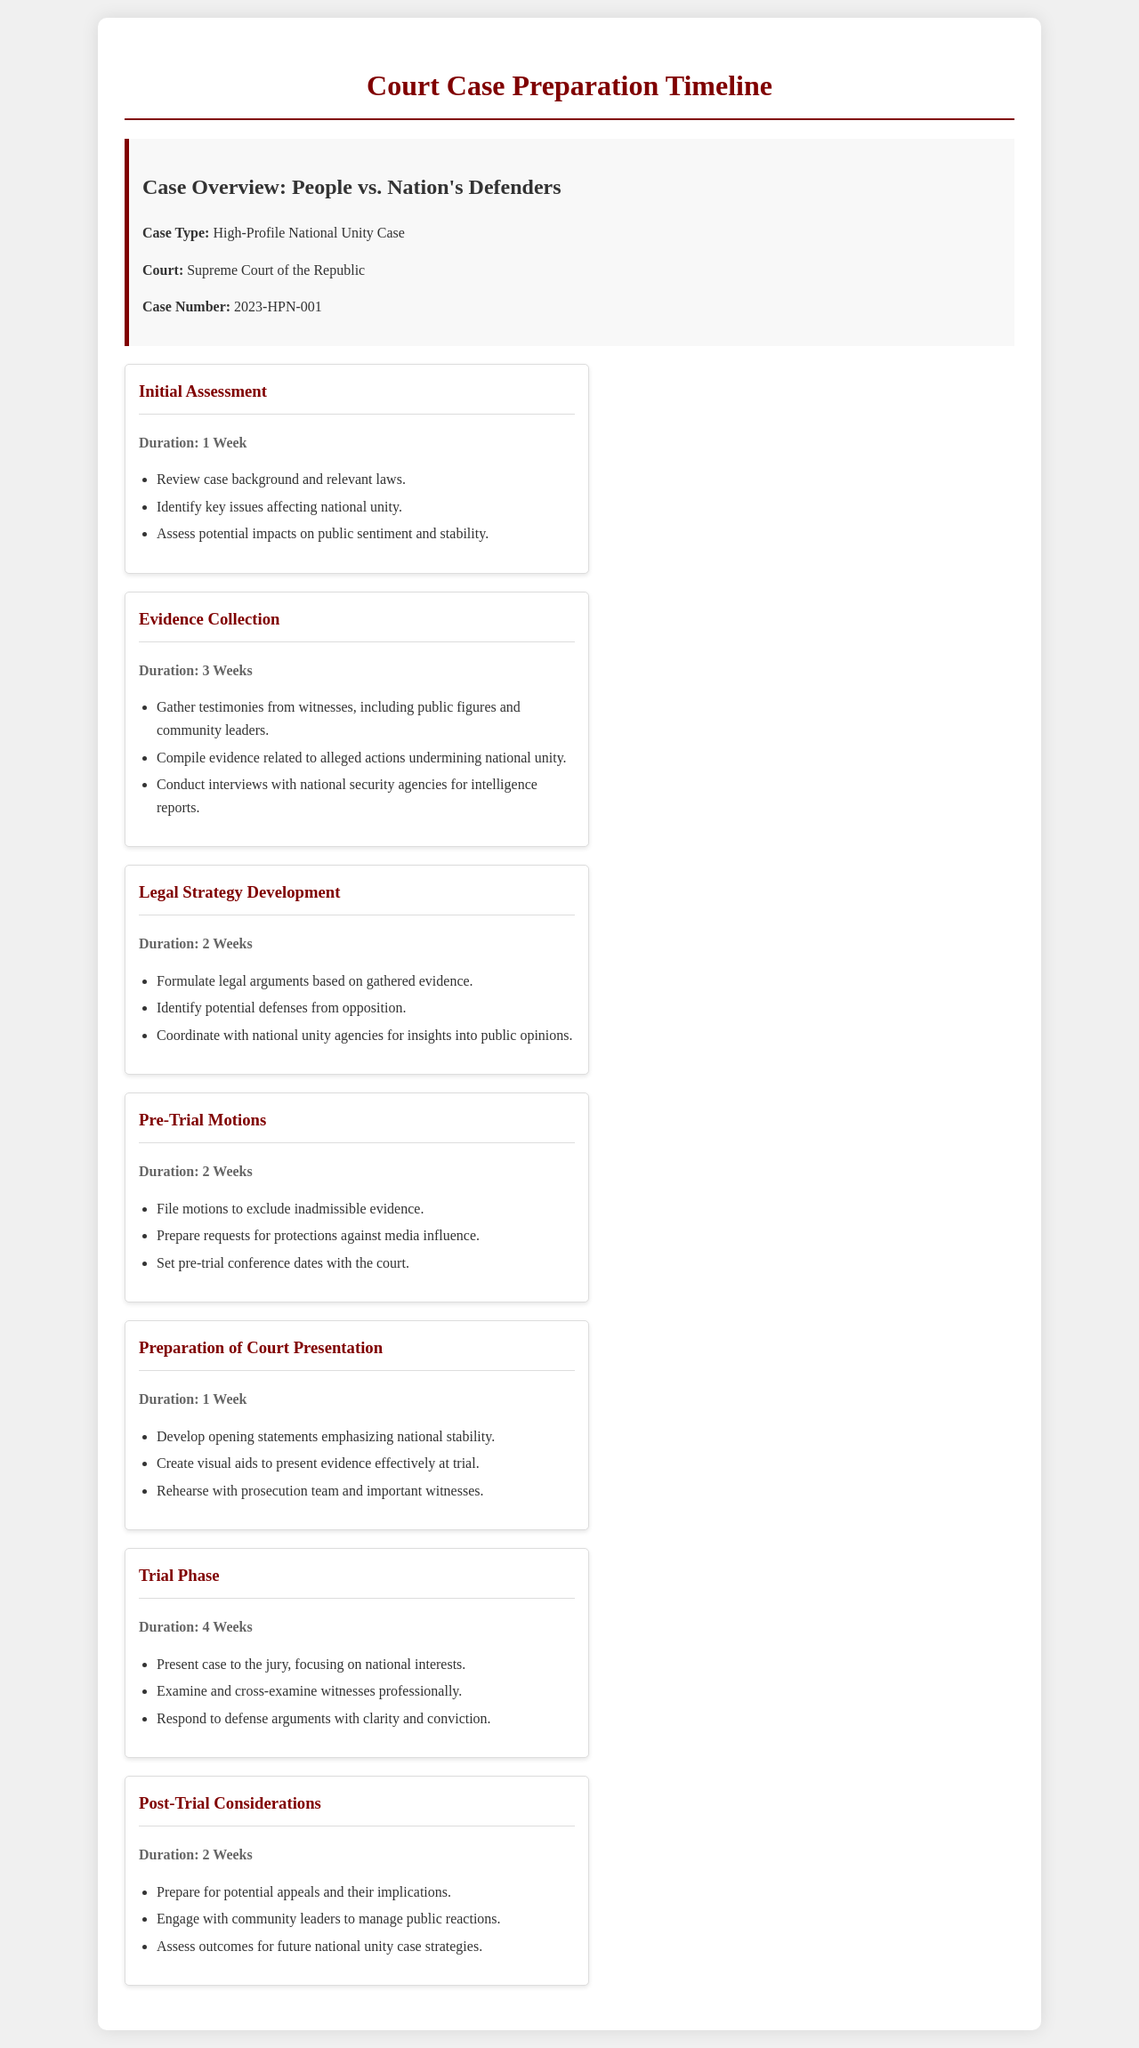What is the case number? The case number is a unique identifier assigned to the case within the judicial system, indicated in the document as 2023-HPN-001.
Answer: 2023-HPN-001 How long is the trial phase? The duration of the trial phase is explicitly mentioned in the timeline as 4 weeks.
Answer: 4 Weeks What is the main focus during the trial phase? The document states that the presentation to the jury will focus on national interests during the trial phase.
Answer: National interests What is the duration of the evidence collection stage? The document provides specific durations for each stage, and evidence collection is noted to last 3 weeks.
Answer: 3 Weeks What preparation is emphasized in the "Preparation of Court Presentation" stage? This stage includes the development of opening statements that emphasize national stability, a crucial element of the case presentation.
Answer: National stability Which stage involves filing motions? The pre-trial motions stage specifically involves filing motions to address various legal matters prior to the trial.
Answer: Pre-Trial Motions How many weeks are dedicated to post-trial considerations? The document clearly states that the post-trial considerations last for a duration of 2 weeks.
Answer: 2 Weeks What is required for the legal strategy development? The formulation of legal arguments based on gathered evidence is a critical requirement during the legal strategy development stage.
Answer: Legal arguments How is the public sentiment assessed in the timeline? The document notes that assessing potential impacts on public sentiment is part of the initial assessment stage.
Answer: Initial Assessment 